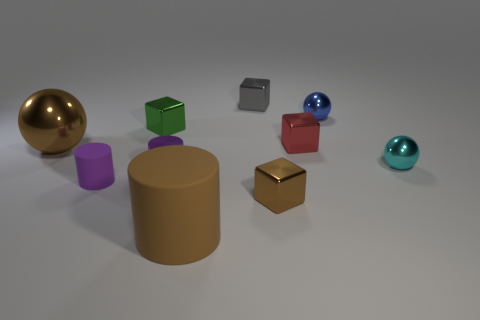What number of brown cylinders are there?
Your response must be concise. 1. There is a shiny sphere that is to the left of the small red cube; what is its size?
Offer a very short reply. Large. Are there an equal number of tiny red metallic things right of the red thing and brown metal objects?
Make the answer very short. No. Is there a large brown rubber thing of the same shape as the purple shiny thing?
Offer a very short reply. Yes. There is a thing that is in front of the small green cube and right of the tiny red metallic block; what is its shape?
Provide a short and direct response. Sphere. Is the cyan object made of the same material as the block that is to the left of the small gray shiny block?
Your response must be concise. Yes. There is a purple matte cylinder; are there any blue metallic spheres on the left side of it?
Offer a very short reply. No. What number of objects are either brown shiny things or metal things in front of the cyan thing?
Your response must be concise. 3. What color is the cylinder that is behind the small purple cylinder that is left of the purple metallic object?
Ensure brevity in your answer.  Purple. What number of other things are there of the same material as the small green object
Offer a terse response. 7. 